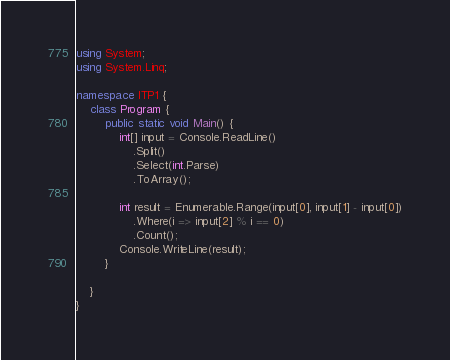Convert code to text. <code><loc_0><loc_0><loc_500><loc_500><_C#_>using System;
using System.Linq;

namespace ITP1 {
	class Program {
		public static void Main() {
			int[] input = Console.ReadLine()
				.Split()
				.Select(int.Parse)
				.ToArray();

			int result = Enumerable.Range(input[0], input[1] - input[0])
				.Where(i => input[2] % i == 0)
				.Count();
			Console.WriteLine(result);
		}

	}
}

</code> 